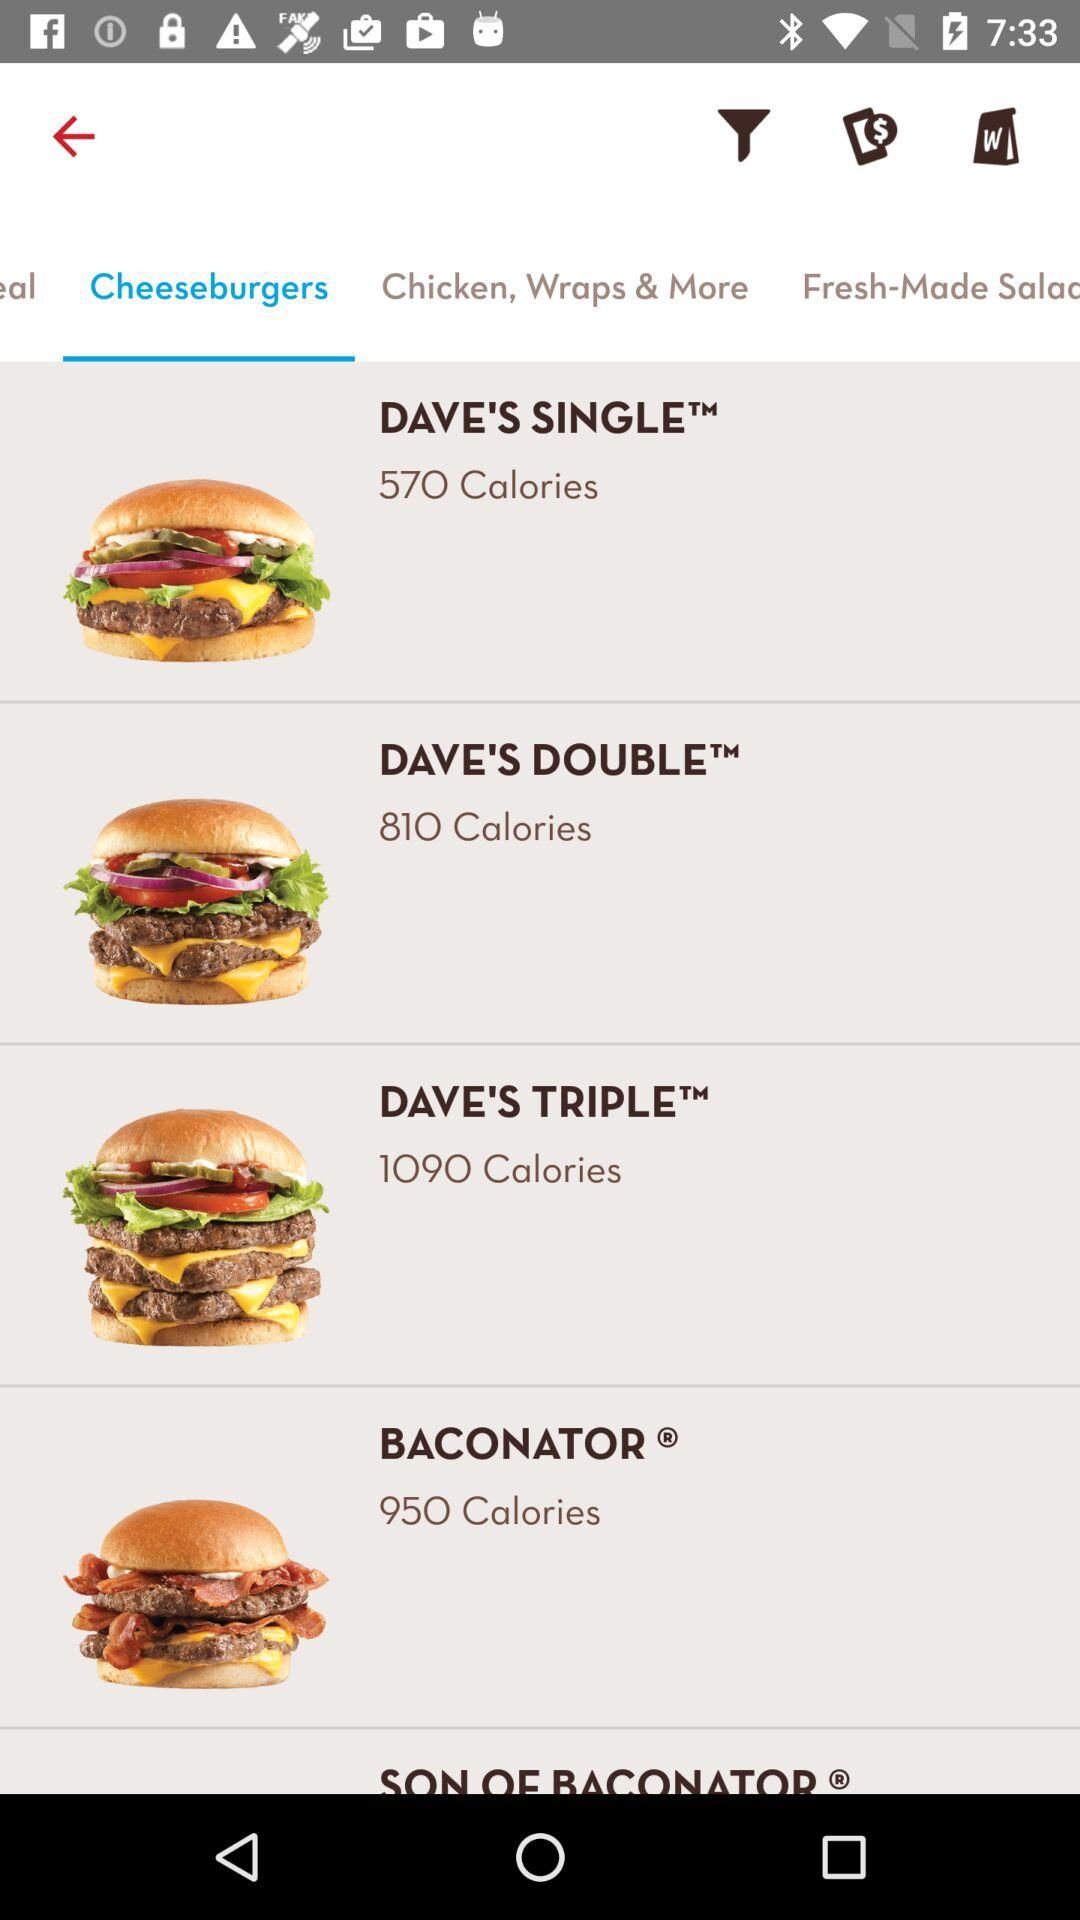How many calories does "SON OF BACONATOR" have?
When the provided information is insufficient, respond with <no answer>. <no answer> 